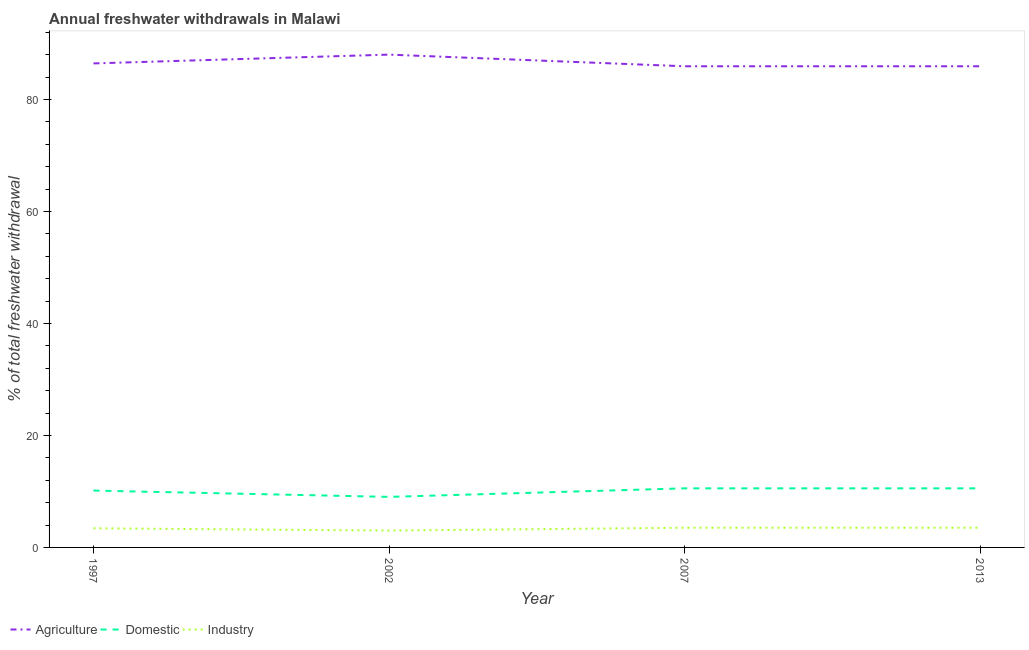How many different coloured lines are there?
Provide a succinct answer. 3. What is the percentage of freshwater withdrawal for domestic purposes in 2013?
Provide a short and direct response. 10.55. Across all years, what is the maximum percentage of freshwater withdrawal for industry?
Provide a succinct answer. 3.52. Across all years, what is the minimum percentage of freshwater withdrawal for agriculture?
Make the answer very short. 85.92. In which year was the percentage of freshwater withdrawal for agriculture maximum?
Make the answer very short. 2002. What is the total percentage of freshwater withdrawal for agriculture in the graph?
Your answer should be compact. 346.27. What is the difference between the percentage of freshwater withdrawal for agriculture in 1997 and that in 2007?
Offer a very short reply. 0.51. What is the difference between the percentage of freshwater withdrawal for agriculture in 1997 and the percentage of freshwater withdrawal for domestic purposes in 2007?
Provide a succinct answer. 75.88. What is the average percentage of freshwater withdrawal for domestic purposes per year?
Your answer should be very brief. 10.07. In the year 1997, what is the difference between the percentage of freshwater withdrawal for domestic purposes and percentage of freshwater withdrawal for agriculture?
Offer a terse response. -76.28. In how many years, is the percentage of freshwater withdrawal for agriculture greater than 76 %?
Make the answer very short. 4. What is the ratio of the percentage of freshwater withdrawal for agriculture in 1997 to that in 2013?
Offer a terse response. 1.01. Is the percentage of freshwater withdrawal for agriculture in 1997 less than that in 2013?
Provide a short and direct response. No. What is the difference between the highest and the second highest percentage of freshwater withdrawal for agriculture?
Offer a terse response. 1.57. What is the difference between the highest and the lowest percentage of freshwater withdrawal for domestic purposes?
Give a very brief answer. 1.52. Is the sum of the percentage of freshwater withdrawal for agriculture in 2002 and 2007 greater than the maximum percentage of freshwater withdrawal for industry across all years?
Offer a very short reply. Yes. Is it the case that in every year, the sum of the percentage of freshwater withdrawal for agriculture and percentage of freshwater withdrawal for domestic purposes is greater than the percentage of freshwater withdrawal for industry?
Provide a succinct answer. Yes. Does the percentage of freshwater withdrawal for industry monotonically increase over the years?
Your answer should be very brief. No. Is the percentage of freshwater withdrawal for domestic purposes strictly greater than the percentage of freshwater withdrawal for agriculture over the years?
Give a very brief answer. No. Is the percentage of freshwater withdrawal for industry strictly less than the percentage of freshwater withdrawal for domestic purposes over the years?
Keep it short and to the point. Yes. How many lines are there?
Offer a very short reply. 3. How many years are there in the graph?
Your answer should be compact. 4. Does the graph contain any zero values?
Ensure brevity in your answer.  No. How many legend labels are there?
Ensure brevity in your answer.  3. How are the legend labels stacked?
Ensure brevity in your answer.  Horizontal. What is the title of the graph?
Your answer should be compact. Annual freshwater withdrawals in Malawi. What is the label or title of the Y-axis?
Ensure brevity in your answer.  % of total freshwater withdrawal. What is the % of total freshwater withdrawal in Agriculture in 1997?
Provide a short and direct response. 86.43. What is the % of total freshwater withdrawal of Domestic in 1997?
Your response must be concise. 10.15. What is the % of total freshwater withdrawal in Industry in 1997?
Give a very brief answer. 3.42. What is the % of total freshwater withdrawal of Agriculture in 2002?
Keep it short and to the point. 88. What is the % of total freshwater withdrawal in Domestic in 2002?
Keep it short and to the point. 9.03. What is the % of total freshwater withdrawal of Industry in 2002?
Give a very brief answer. 3.01. What is the % of total freshwater withdrawal in Agriculture in 2007?
Your answer should be compact. 85.92. What is the % of total freshwater withdrawal in Domestic in 2007?
Offer a very short reply. 10.55. What is the % of total freshwater withdrawal of Industry in 2007?
Provide a succinct answer. 3.52. What is the % of total freshwater withdrawal of Agriculture in 2013?
Keep it short and to the point. 85.92. What is the % of total freshwater withdrawal of Domestic in 2013?
Provide a succinct answer. 10.55. What is the % of total freshwater withdrawal of Industry in 2013?
Offer a very short reply. 3.52. Across all years, what is the maximum % of total freshwater withdrawal of Agriculture?
Provide a short and direct response. 88. Across all years, what is the maximum % of total freshwater withdrawal of Domestic?
Provide a succinct answer. 10.55. Across all years, what is the maximum % of total freshwater withdrawal of Industry?
Your answer should be compact. 3.52. Across all years, what is the minimum % of total freshwater withdrawal in Agriculture?
Give a very brief answer. 85.92. Across all years, what is the minimum % of total freshwater withdrawal of Domestic?
Offer a very short reply. 9.03. Across all years, what is the minimum % of total freshwater withdrawal in Industry?
Give a very brief answer. 3.01. What is the total % of total freshwater withdrawal of Agriculture in the graph?
Give a very brief answer. 346.27. What is the total % of total freshwater withdrawal of Domestic in the graph?
Your answer should be compact. 40.28. What is the total % of total freshwater withdrawal in Industry in the graph?
Offer a very short reply. 13.46. What is the difference between the % of total freshwater withdrawal in Agriculture in 1997 and that in 2002?
Your answer should be compact. -1.57. What is the difference between the % of total freshwater withdrawal in Domestic in 1997 and that in 2002?
Keep it short and to the point. 1.12. What is the difference between the % of total freshwater withdrawal in Industry in 1997 and that in 2002?
Your answer should be compact. 0.41. What is the difference between the % of total freshwater withdrawal in Agriculture in 1997 and that in 2007?
Your answer should be very brief. 0.51. What is the difference between the % of total freshwater withdrawal of Domestic in 1997 and that in 2007?
Ensure brevity in your answer.  -0.4. What is the difference between the % of total freshwater withdrawal in Industry in 1997 and that in 2007?
Provide a succinct answer. -0.1. What is the difference between the % of total freshwater withdrawal in Agriculture in 1997 and that in 2013?
Give a very brief answer. 0.51. What is the difference between the % of total freshwater withdrawal in Industry in 1997 and that in 2013?
Make the answer very short. -0.1. What is the difference between the % of total freshwater withdrawal of Agriculture in 2002 and that in 2007?
Provide a succinct answer. 2.08. What is the difference between the % of total freshwater withdrawal of Domestic in 2002 and that in 2007?
Your response must be concise. -1.52. What is the difference between the % of total freshwater withdrawal of Industry in 2002 and that in 2007?
Keep it short and to the point. -0.5. What is the difference between the % of total freshwater withdrawal in Agriculture in 2002 and that in 2013?
Offer a very short reply. 2.08. What is the difference between the % of total freshwater withdrawal of Domestic in 2002 and that in 2013?
Your answer should be compact. -1.52. What is the difference between the % of total freshwater withdrawal in Industry in 2002 and that in 2013?
Provide a short and direct response. -0.5. What is the difference between the % of total freshwater withdrawal of Agriculture in 2007 and that in 2013?
Give a very brief answer. 0. What is the difference between the % of total freshwater withdrawal in Domestic in 2007 and that in 2013?
Give a very brief answer. 0. What is the difference between the % of total freshwater withdrawal in Industry in 2007 and that in 2013?
Offer a terse response. 0. What is the difference between the % of total freshwater withdrawal of Agriculture in 1997 and the % of total freshwater withdrawal of Domestic in 2002?
Your answer should be very brief. 77.4. What is the difference between the % of total freshwater withdrawal of Agriculture in 1997 and the % of total freshwater withdrawal of Industry in 2002?
Your response must be concise. 83.42. What is the difference between the % of total freshwater withdrawal in Domestic in 1997 and the % of total freshwater withdrawal in Industry in 2002?
Offer a terse response. 7.14. What is the difference between the % of total freshwater withdrawal of Agriculture in 1997 and the % of total freshwater withdrawal of Domestic in 2007?
Keep it short and to the point. 75.88. What is the difference between the % of total freshwater withdrawal in Agriculture in 1997 and the % of total freshwater withdrawal in Industry in 2007?
Provide a succinct answer. 82.92. What is the difference between the % of total freshwater withdrawal in Domestic in 1997 and the % of total freshwater withdrawal in Industry in 2007?
Make the answer very short. 6.63. What is the difference between the % of total freshwater withdrawal in Agriculture in 1997 and the % of total freshwater withdrawal in Domestic in 2013?
Give a very brief answer. 75.88. What is the difference between the % of total freshwater withdrawal of Agriculture in 1997 and the % of total freshwater withdrawal of Industry in 2013?
Keep it short and to the point. 82.92. What is the difference between the % of total freshwater withdrawal of Domestic in 1997 and the % of total freshwater withdrawal of Industry in 2013?
Make the answer very short. 6.63. What is the difference between the % of total freshwater withdrawal of Agriculture in 2002 and the % of total freshwater withdrawal of Domestic in 2007?
Provide a short and direct response. 77.45. What is the difference between the % of total freshwater withdrawal in Agriculture in 2002 and the % of total freshwater withdrawal in Industry in 2007?
Provide a short and direct response. 84.48. What is the difference between the % of total freshwater withdrawal in Domestic in 2002 and the % of total freshwater withdrawal in Industry in 2007?
Offer a very short reply. 5.51. What is the difference between the % of total freshwater withdrawal of Agriculture in 2002 and the % of total freshwater withdrawal of Domestic in 2013?
Offer a terse response. 77.45. What is the difference between the % of total freshwater withdrawal of Agriculture in 2002 and the % of total freshwater withdrawal of Industry in 2013?
Your response must be concise. 84.48. What is the difference between the % of total freshwater withdrawal of Domestic in 2002 and the % of total freshwater withdrawal of Industry in 2013?
Your answer should be compact. 5.51. What is the difference between the % of total freshwater withdrawal in Agriculture in 2007 and the % of total freshwater withdrawal in Domestic in 2013?
Your answer should be compact. 75.37. What is the difference between the % of total freshwater withdrawal of Agriculture in 2007 and the % of total freshwater withdrawal of Industry in 2013?
Ensure brevity in your answer.  82.41. What is the difference between the % of total freshwater withdrawal in Domestic in 2007 and the % of total freshwater withdrawal in Industry in 2013?
Keep it short and to the point. 7.04. What is the average % of total freshwater withdrawal of Agriculture per year?
Give a very brief answer. 86.57. What is the average % of total freshwater withdrawal in Domestic per year?
Give a very brief answer. 10.07. What is the average % of total freshwater withdrawal of Industry per year?
Ensure brevity in your answer.  3.37. In the year 1997, what is the difference between the % of total freshwater withdrawal in Agriculture and % of total freshwater withdrawal in Domestic?
Provide a succinct answer. 76.28. In the year 1997, what is the difference between the % of total freshwater withdrawal of Agriculture and % of total freshwater withdrawal of Industry?
Provide a succinct answer. 83.01. In the year 1997, what is the difference between the % of total freshwater withdrawal in Domestic and % of total freshwater withdrawal in Industry?
Offer a terse response. 6.73. In the year 2002, what is the difference between the % of total freshwater withdrawal in Agriculture and % of total freshwater withdrawal in Domestic?
Offer a very short reply. 78.97. In the year 2002, what is the difference between the % of total freshwater withdrawal in Agriculture and % of total freshwater withdrawal in Industry?
Provide a short and direct response. 84.99. In the year 2002, what is the difference between the % of total freshwater withdrawal of Domestic and % of total freshwater withdrawal of Industry?
Provide a short and direct response. 6.01. In the year 2007, what is the difference between the % of total freshwater withdrawal of Agriculture and % of total freshwater withdrawal of Domestic?
Give a very brief answer. 75.37. In the year 2007, what is the difference between the % of total freshwater withdrawal in Agriculture and % of total freshwater withdrawal in Industry?
Your answer should be very brief. 82.41. In the year 2007, what is the difference between the % of total freshwater withdrawal in Domestic and % of total freshwater withdrawal in Industry?
Provide a short and direct response. 7.04. In the year 2013, what is the difference between the % of total freshwater withdrawal of Agriculture and % of total freshwater withdrawal of Domestic?
Offer a terse response. 75.37. In the year 2013, what is the difference between the % of total freshwater withdrawal in Agriculture and % of total freshwater withdrawal in Industry?
Offer a very short reply. 82.41. In the year 2013, what is the difference between the % of total freshwater withdrawal of Domestic and % of total freshwater withdrawal of Industry?
Offer a very short reply. 7.04. What is the ratio of the % of total freshwater withdrawal in Agriculture in 1997 to that in 2002?
Your answer should be very brief. 0.98. What is the ratio of the % of total freshwater withdrawal in Domestic in 1997 to that in 2002?
Your response must be concise. 1.12. What is the ratio of the % of total freshwater withdrawal of Industry in 1997 to that in 2002?
Offer a very short reply. 1.14. What is the ratio of the % of total freshwater withdrawal in Agriculture in 1997 to that in 2007?
Ensure brevity in your answer.  1.01. What is the ratio of the % of total freshwater withdrawal in Domestic in 1997 to that in 2007?
Provide a short and direct response. 0.96. What is the ratio of the % of total freshwater withdrawal in Industry in 1997 to that in 2007?
Offer a very short reply. 0.97. What is the ratio of the % of total freshwater withdrawal of Agriculture in 1997 to that in 2013?
Your answer should be compact. 1.01. What is the ratio of the % of total freshwater withdrawal in Domestic in 1997 to that in 2013?
Keep it short and to the point. 0.96. What is the ratio of the % of total freshwater withdrawal in Industry in 1997 to that in 2013?
Provide a short and direct response. 0.97. What is the ratio of the % of total freshwater withdrawal of Agriculture in 2002 to that in 2007?
Your answer should be compact. 1.02. What is the ratio of the % of total freshwater withdrawal in Domestic in 2002 to that in 2007?
Keep it short and to the point. 0.86. What is the ratio of the % of total freshwater withdrawal in Industry in 2002 to that in 2007?
Provide a short and direct response. 0.86. What is the ratio of the % of total freshwater withdrawal in Agriculture in 2002 to that in 2013?
Your response must be concise. 1.02. What is the ratio of the % of total freshwater withdrawal of Domestic in 2002 to that in 2013?
Provide a succinct answer. 0.86. What is the ratio of the % of total freshwater withdrawal of Industry in 2002 to that in 2013?
Offer a terse response. 0.86. What is the ratio of the % of total freshwater withdrawal of Domestic in 2007 to that in 2013?
Provide a short and direct response. 1. What is the ratio of the % of total freshwater withdrawal in Industry in 2007 to that in 2013?
Your response must be concise. 1. What is the difference between the highest and the second highest % of total freshwater withdrawal in Agriculture?
Your answer should be compact. 1.57. What is the difference between the highest and the second highest % of total freshwater withdrawal of Industry?
Offer a very short reply. 0. What is the difference between the highest and the lowest % of total freshwater withdrawal in Agriculture?
Give a very brief answer. 2.08. What is the difference between the highest and the lowest % of total freshwater withdrawal of Domestic?
Ensure brevity in your answer.  1.52. What is the difference between the highest and the lowest % of total freshwater withdrawal of Industry?
Provide a succinct answer. 0.5. 